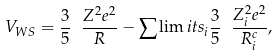<formula> <loc_0><loc_0><loc_500><loc_500>V _ { W S } = \frac { 3 } { 5 } \ \frac { Z ^ { 2 } e ^ { 2 } } { R } - \sum \lim i t s _ { i } \frac { 3 } { 5 } \ \frac { Z _ { i } ^ { 2 } e ^ { 2 } } { R _ { i } ^ { c } } ,</formula> 